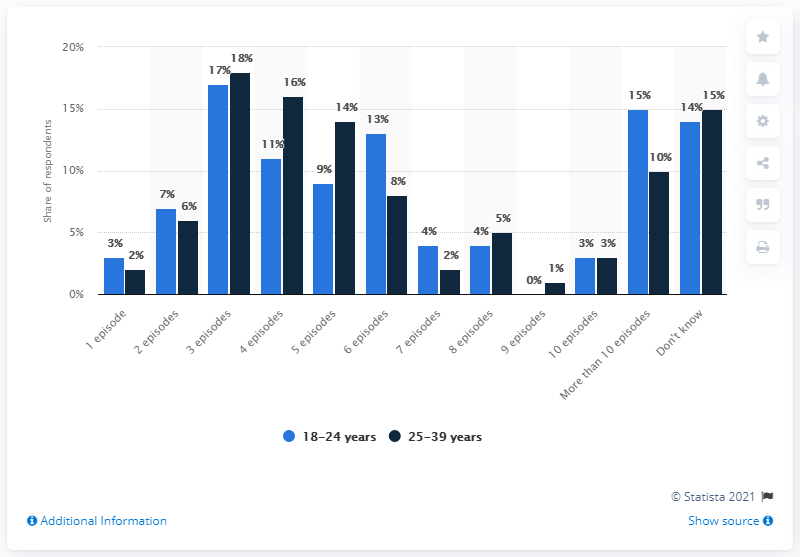Identify some key points in this picture. The maximum difference between a navy blue bar and a light blue bar is 5. According to our data, 3% of individuals between the ages of 25-39 watch 10 or more episodes in a single binge-watching session. 